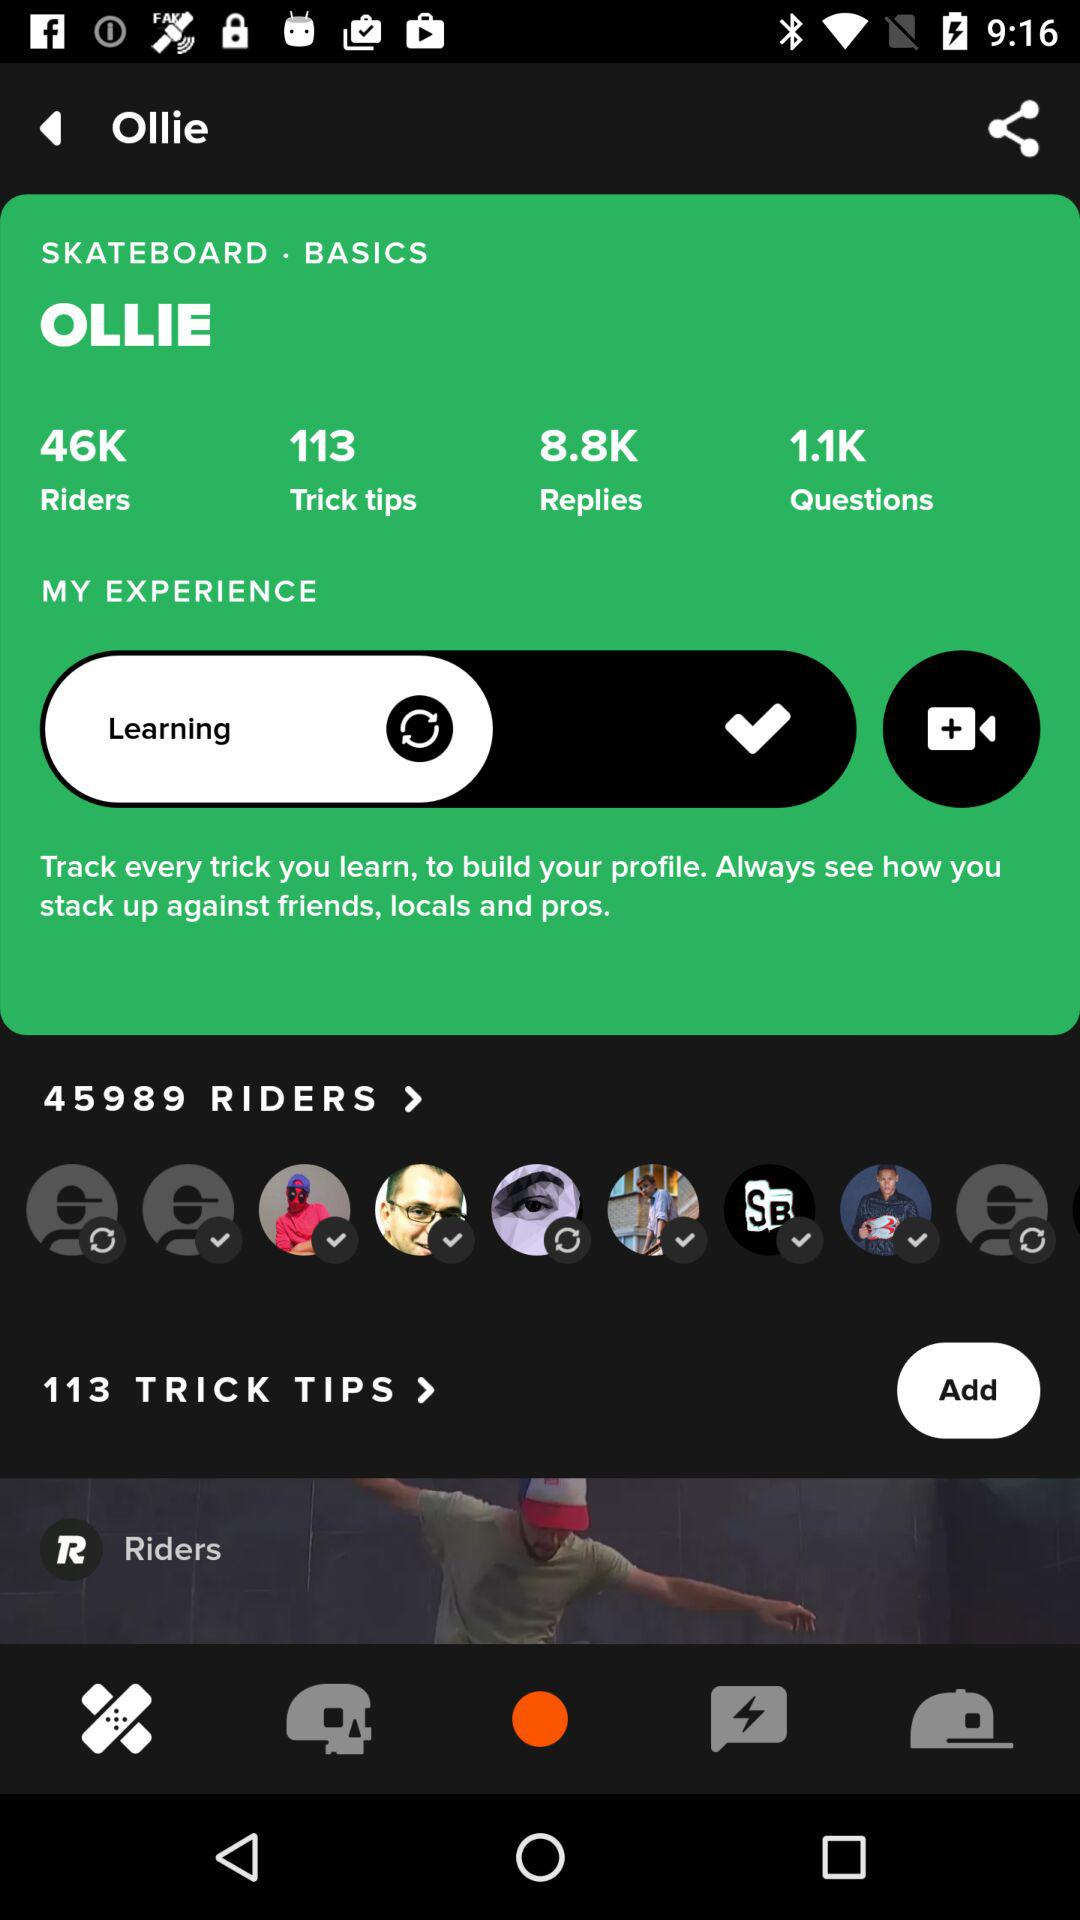What is the count for trick tips? The count for trick tips is 113. 